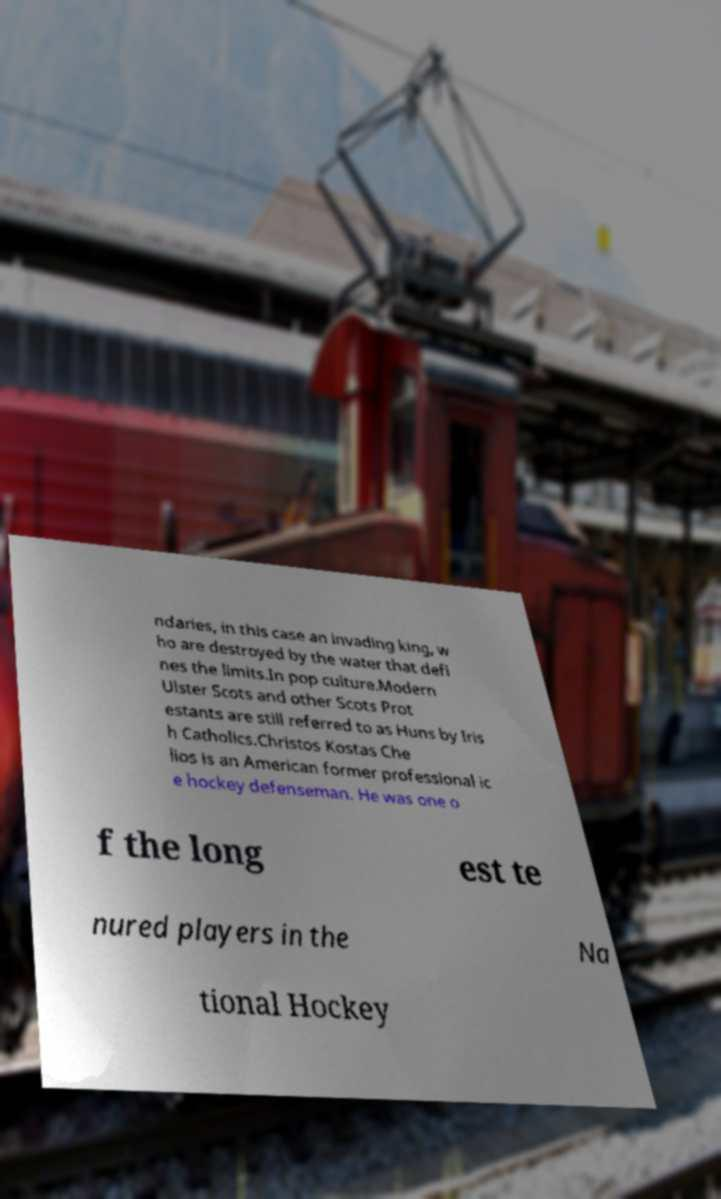There's text embedded in this image that I need extracted. Can you transcribe it verbatim? ndaries, in this case an invading king, w ho are destroyed by the water that defi nes the limits.In pop culture.Modern Ulster Scots and other Scots Prot estants are still referred to as Huns by Iris h Catholics.Christos Kostas Che lios is an American former professional ic e hockey defenseman. He was one o f the long est te nured players in the Na tional Hockey 